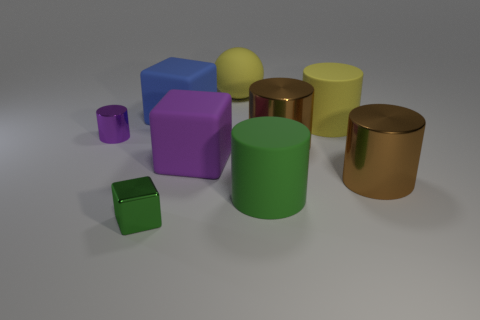How many other objects are there of the same material as the green block? Starting with the green block in the image, there are three other objects that appear to be made of a similar matte material. These include a smaller green cube, a violet cube, and a smaller purple cube. 